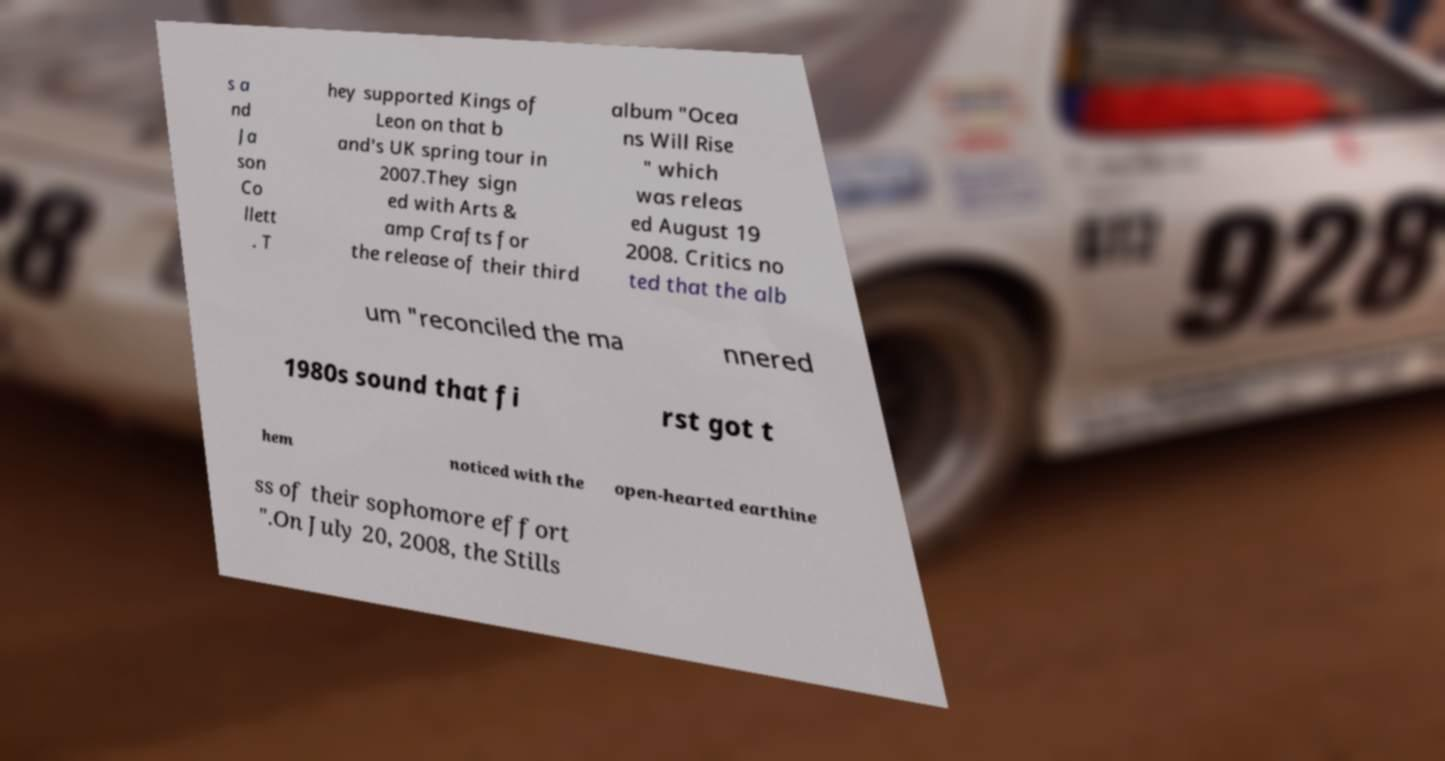Could you extract and type out the text from this image? s a nd Ja son Co llett . T hey supported Kings of Leon on that b and's UK spring tour in 2007.They sign ed with Arts & amp Crafts for the release of their third album "Ocea ns Will Rise " which was releas ed August 19 2008. Critics no ted that the alb um "reconciled the ma nnered 1980s sound that fi rst got t hem noticed with the open-hearted earthine ss of their sophomore effort ".On July 20, 2008, the Stills 